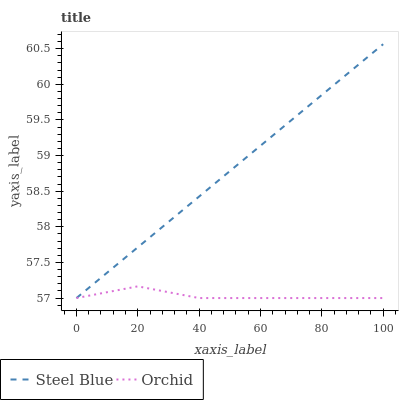Does Orchid have the minimum area under the curve?
Answer yes or no. Yes. Does Steel Blue have the maximum area under the curve?
Answer yes or no. Yes. Does Orchid have the maximum area under the curve?
Answer yes or no. No. Is Steel Blue the smoothest?
Answer yes or no. Yes. Is Orchid the roughest?
Answer yes or no. Yes. Is Orchid the smoothest?
Answer yes or no. No. Does Orchid have the highest value?
Answer yes or no. No. 